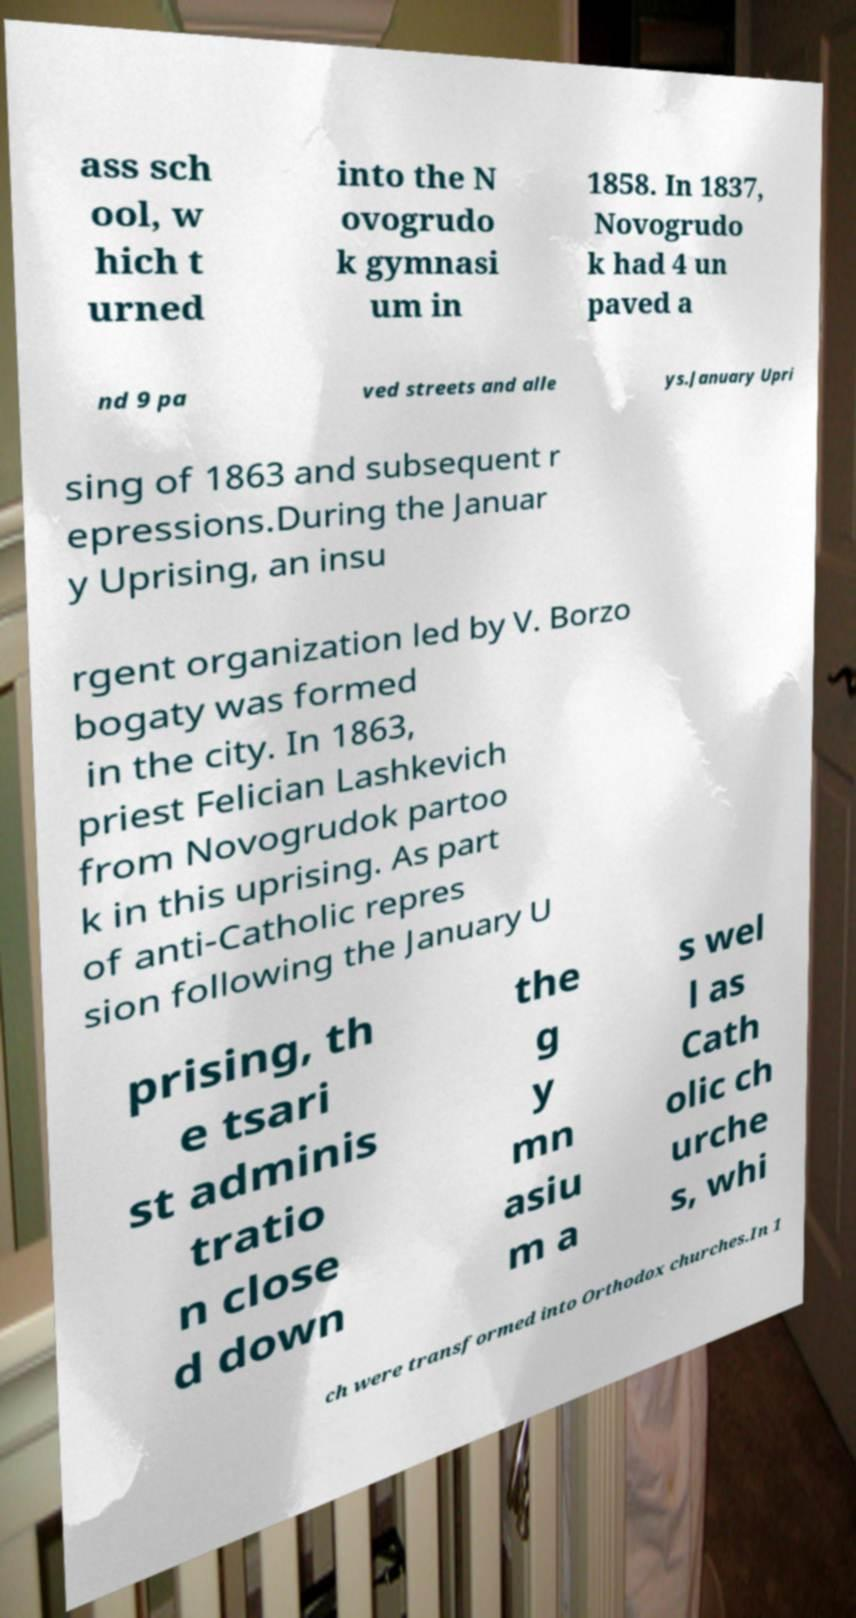Could you assist in decoding the text presented in this image and type it out clearly? ass sch ool, w hich t urned into the N ovogrudo k gymnasi um in 1858. In 1837, Novogrudo k had 4 un paved a nd 9 pa ved streets and alle ys.January Upri sing of 1863 and subsequent r epressions.During the Januar y Uprising, an insu rgent organization led by V. Borzo bogaty was formed in the city. In 1863, priest Felician Lashkevich from Novogrudok partoo k in this uprising. As part of anti-Catholic repres sion following the January U prising, th e tsari st adminis tratio n close d down the g y mn asiu m a s wel l as Cath olic ch urche s, whi ch were transformed into Orthodox churches.In 1 